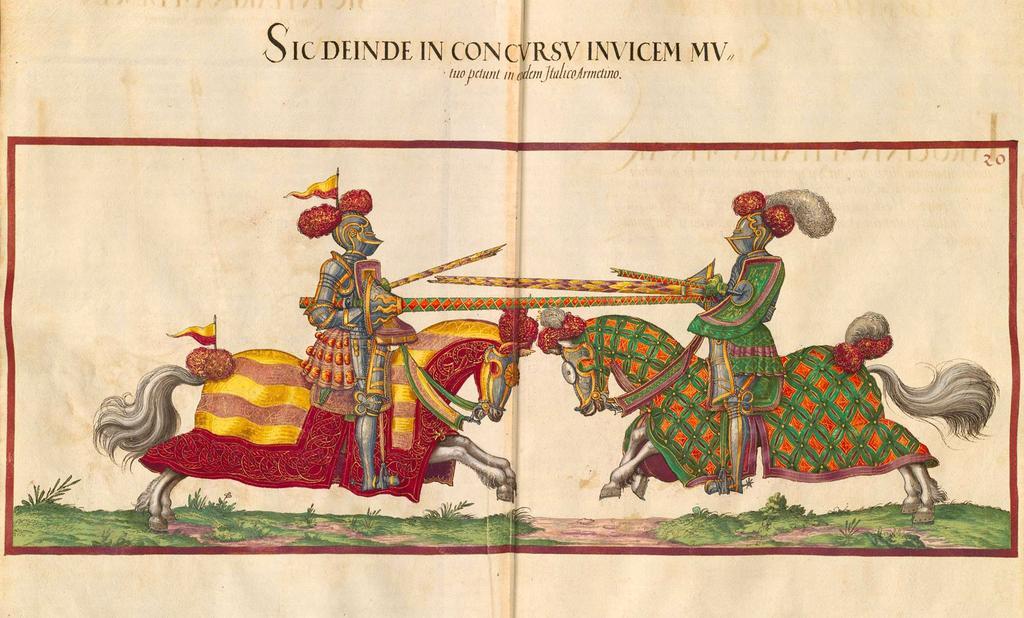In one or two sentences, can you explain what this image depicts? In this image we can see a poster of persons sitting on the horses. We can see few plants and grass on a surface. At the top we can see some text. 